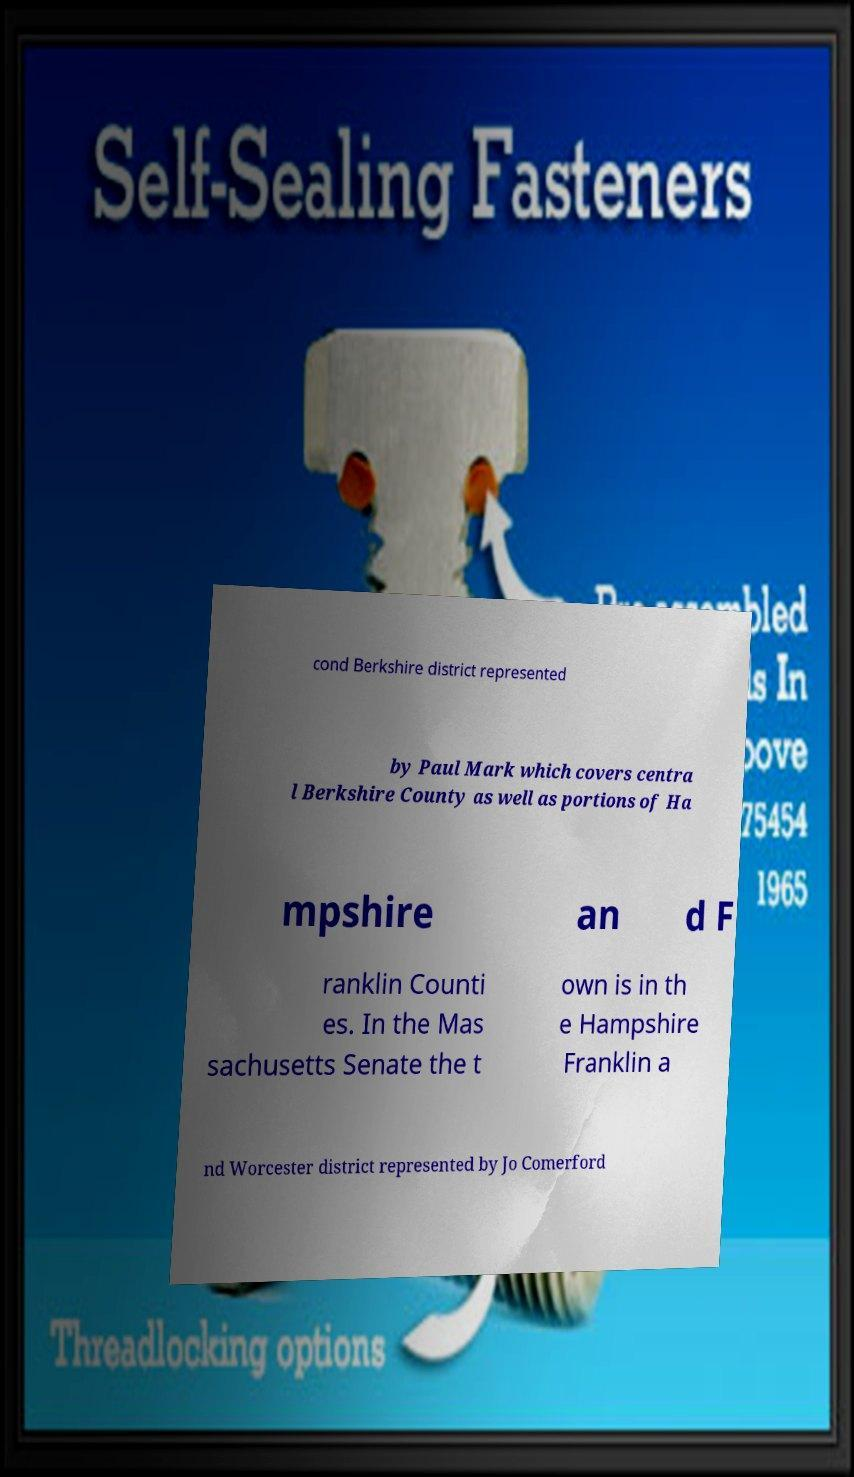Could you extract and type out the text from this image? cond Berkshire district represented by Paul Mark which covers centra l Berkshire County as well as portions of Ha mpshire an d F ranklin Counti es. In the Mas sachusetts Senate the t own is in th e Hampshire Franklin a nd Worcester district represented by Jo Comerford 